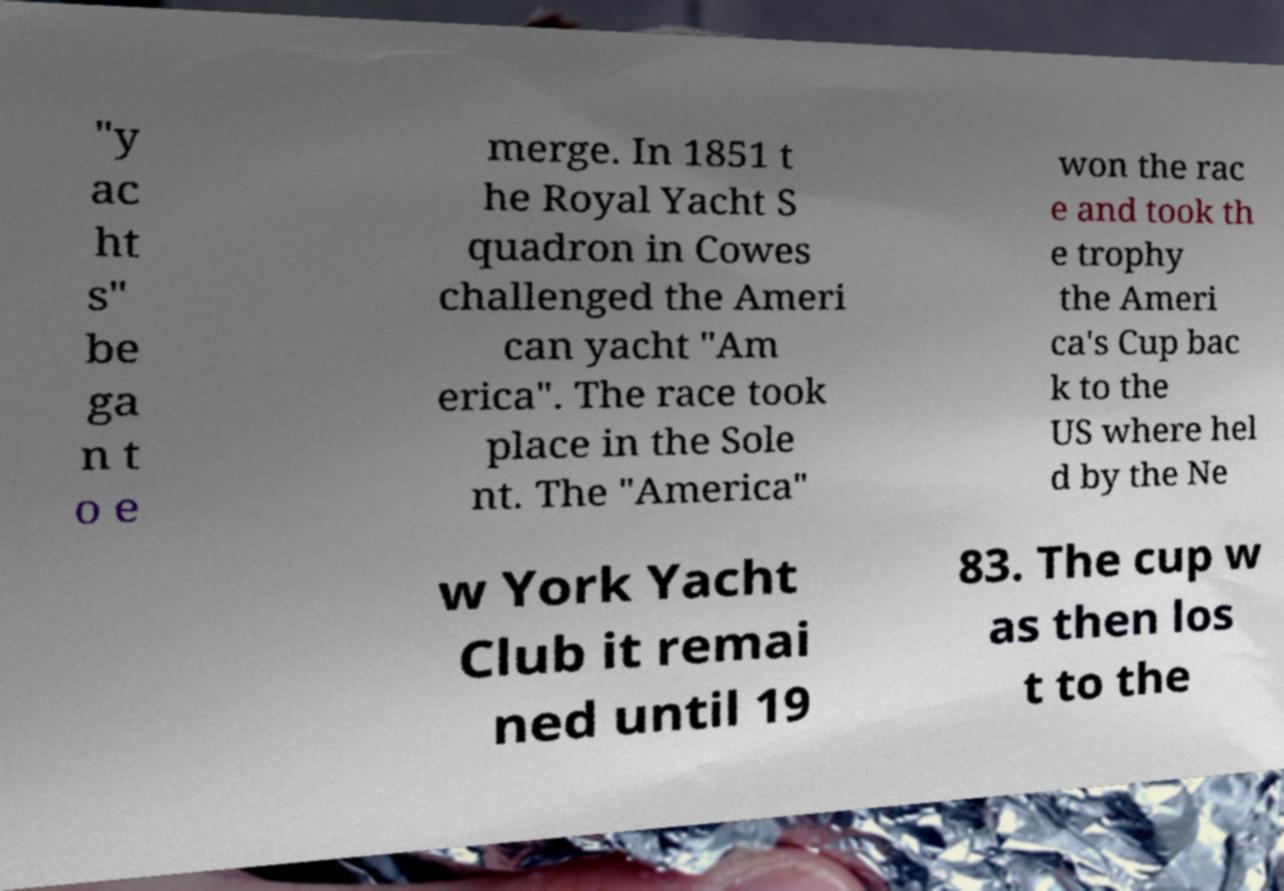Can you read and provide the text displayed in the image?This photo seems to have some interesting text. Can you extract and type it out for me? "y ac ht s" be ga n t o e merge. In 1851 t he Royal Yacht S quadron in Cowes challenged the Ameri can yacht "Am erica". The race took place in the Sole nt. The "America" won the rac e and took th e trophy the Ameri ca's Cup bac k to the US where hel d by the Ne w York Yacht Club it remai ned until 19 83. The cup w as then los t to the 